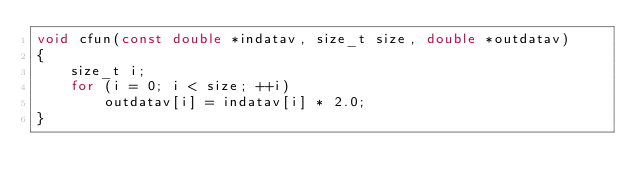Convert code to text. <code><loc_0><loc_0><loc_500><loc_500><_C_>void cfun(const double *indatav, size_t size, double *outdatav) 
{
    size_t i;
    for (i = 0; i < size; ++i)
        outdatav[i] = indatav[i] * 2.0;
}
</code> 